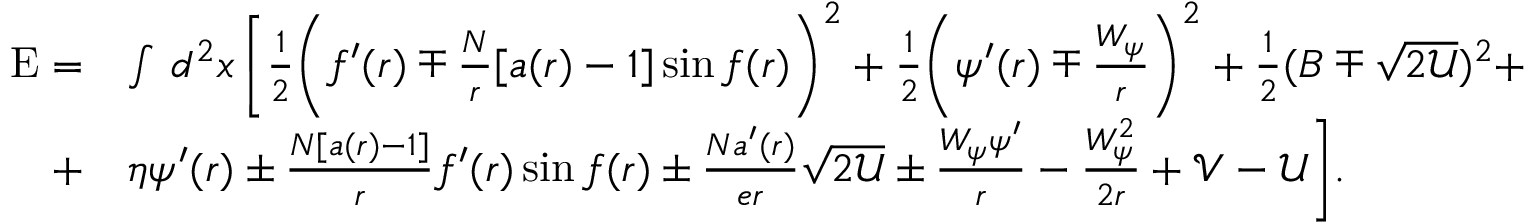<formula> <loc_0><loc_0><loc_500><loc_500>\begin{array} { r l } { E = } & { \int \, d ^ { 2 } x \, \left [ \frac { 1 } { 2 } \left ( f ^ { \prime } ( r ) \mp \frac { N } { r } [ a ( r ) - 1 ] \sin f ( r ) \right ) ^ { 2 } + \frac { 1 } { 2 } \left ( \psi ^ { \prime } ( r ) \mp \frac { W _ { \psi } } { r } \right ) ^ { 2 } + \frac { 1 } { 2 } ( B \mp \sqrt { 2 \mathcal { U } } ) ^ { 2 } + } \\ { + } & { \eta \psi ^ { \prime } ( r ) \pm \frac { N [ a ( r ) - 1 ] } { r } f ^ { \prime } ( r ) \sin f ( r ) \pm \frac { N a ^ { \prime } ( r ) } { e r } \sqrt { 2 \mathcal { U } } \pm \frac { W _ { \psi } \psi ^ { \prime } } { r } - \frac { W _ { \psi } ^ { 2 } } { 2 r } + \mathcal { V } - \mathcal { U } \right ] . } \end{array}</formula> 